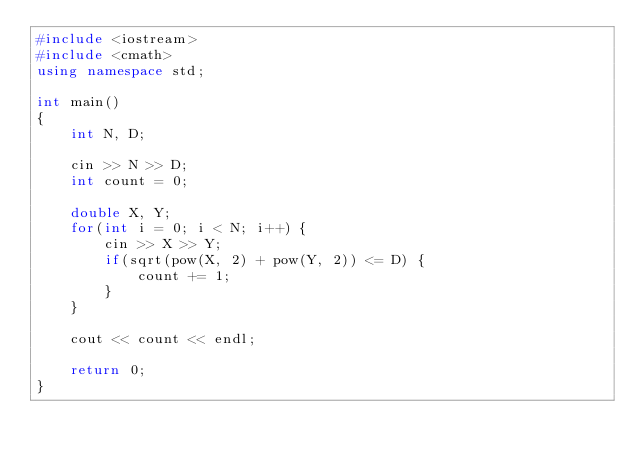<code> <loc_0><loc_0><loc_500><loc_500><_C++_>#include <iostream>
#include <cmath>
using namespace std;

int main()
{
    int N, D;

    cin >> N >> D;
    int count = 0;

    double X, Y;
    for(int i = 0; i < N; i++) {
        cin >> X >> Y;
        if(sqrt(pow(X, 2) + pow(Y, 2)) <= D) {
            count += 1;
        }
    }

    cout << count << endl;

    return 0;
}</code> 